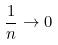Convert formula to latex. <formula><loc_0><loc_0><loc_500><loc_500>\frac { 1 } { n } \rightarrow 0</formula> 